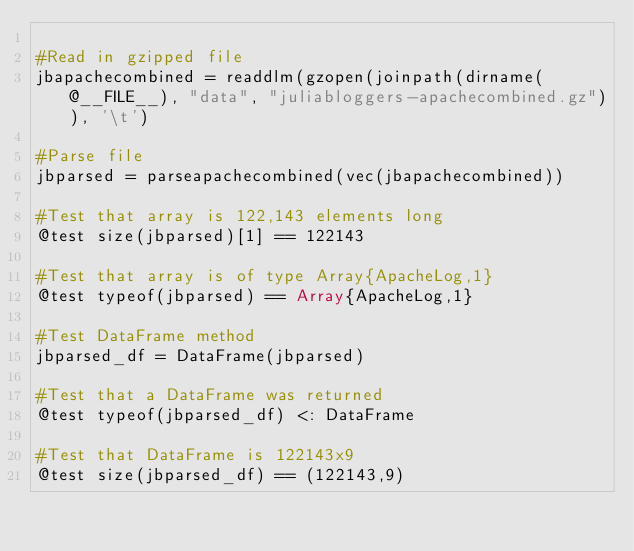Convert code to text. <code><loc_0><loc_0><loc_500><loc_500><_Julia_>
#Read in gzipped file
jbapachecombined = readdlm(gzopen(joinpath(dirname(@__FILE__), "data", "juliabloggers-apachecombined.gz")), '\t')

#Parse file
jbparsed = parseapachecombined(vec(jbapachecombined))

#Test that array is 122,143 elements long
@test size(jbparsed)[1] == 122143

#Test that array is of type Array{ApacheLog,1}
@test typeof(jbparsed) == Array{ApacheLog,1}

#Test DataFrame method
jbparsed_df = DataFrame(jbparsed)

#Test that a DataFrame was returned
@test typeof(jbparsed_df) <: DataFrame

#Test that DataFrame is 122143x9
@test size(jbparsed_df) == (122143,9)
</code> 